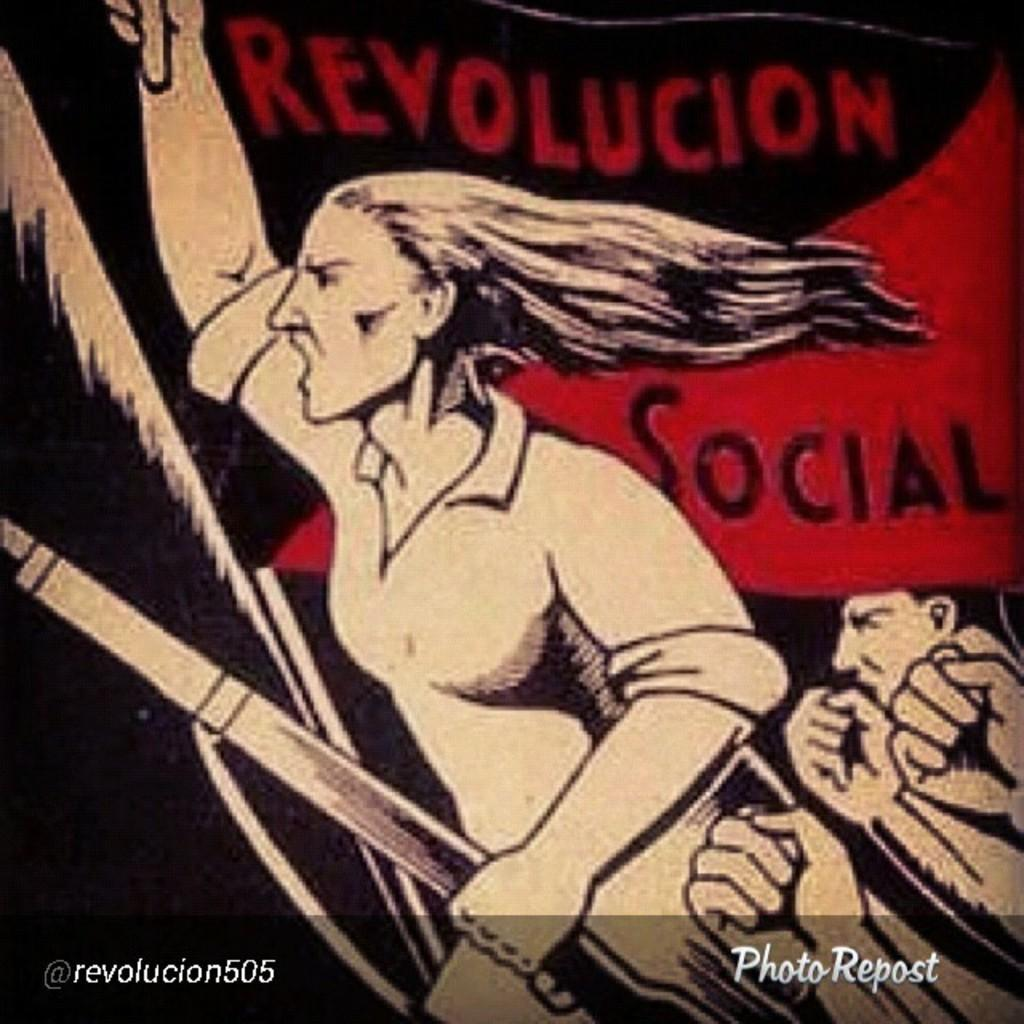<image>
Offer a succinct explanation of the picture presented. a flag with a woman that says Revolucion and Social is red and black 